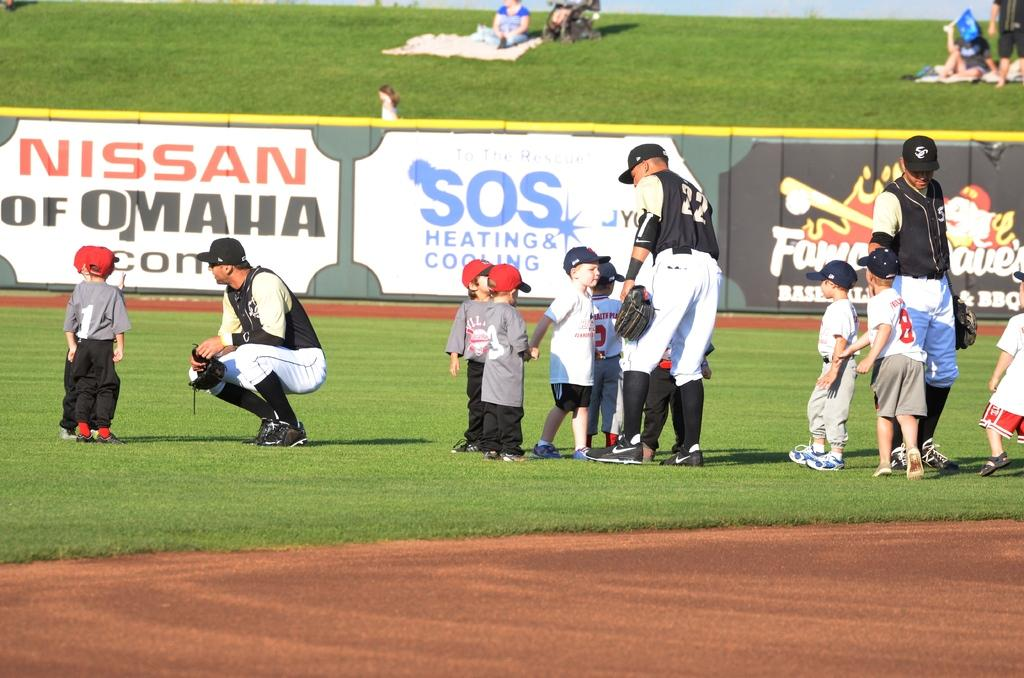Provide a one-sentence caption for the provided image. small kids speaking with adult ball players with a nissan of omaha banner in the background. 